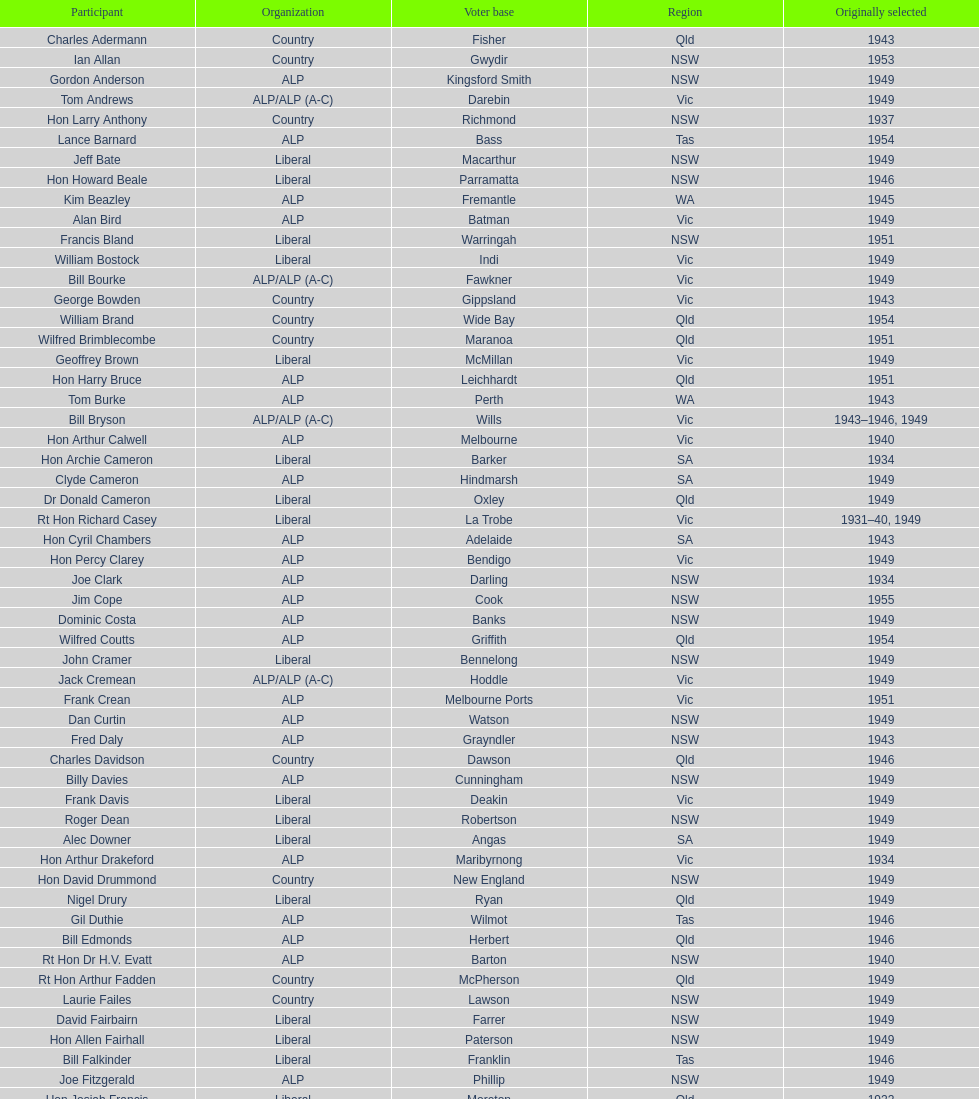Previous to tom andrews who was elected? Gordon Anderson. 